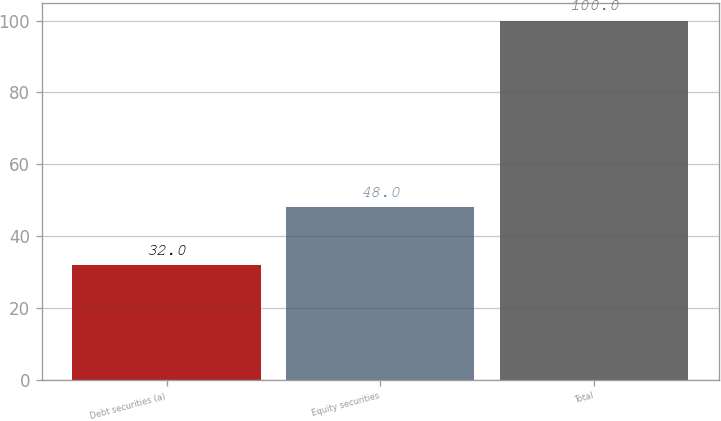<chart> <loc_0><loc_0><loc_500><loc_500><bar_chart><fcel>Debt securities (a)<fcel>Equity securities<fcel>Total<nl><fcel>32<fcel>48<fcel>100<nl></chart> 